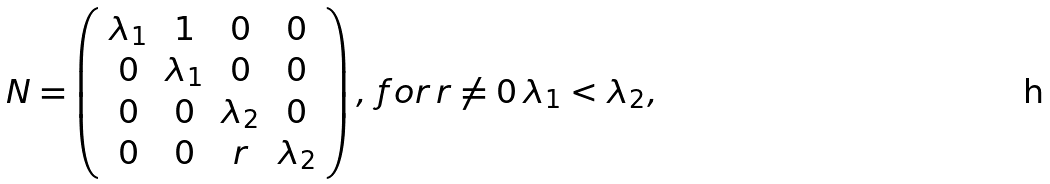Convert formula to latex. <formula><loc_0><loc_0><loc_500><loc_500>N = \left ( \begin{array} { c c c c } \lambda _ { 1 } & 1 & 0 & 0 \\ 0 & \lambda _ { 1 } & 0 & 0 \\ 0 & 0 & \lambda _ { 2 } & 0 \\ 0 & 0 & r & \lambda _ { 2 } \end{array} \right ) , \, f o r \, r \neq 0 \, \lambda _ { 1 } < \lambda _ { 2 } ,</formula> 